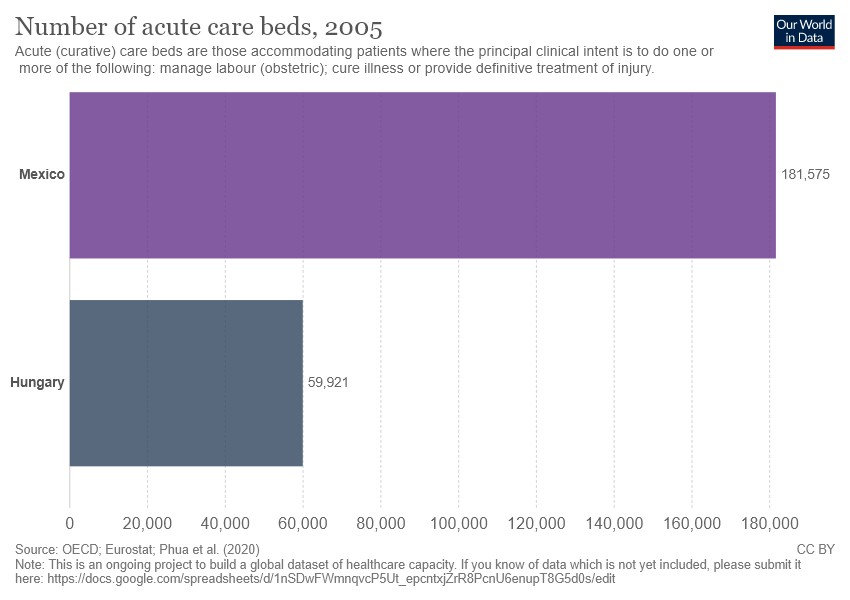Draw attention to some important aspects in this diagram. Mexico has a greater number of acute care beds compared to other countries. The average value of two bars is greater than 1,00,000. 